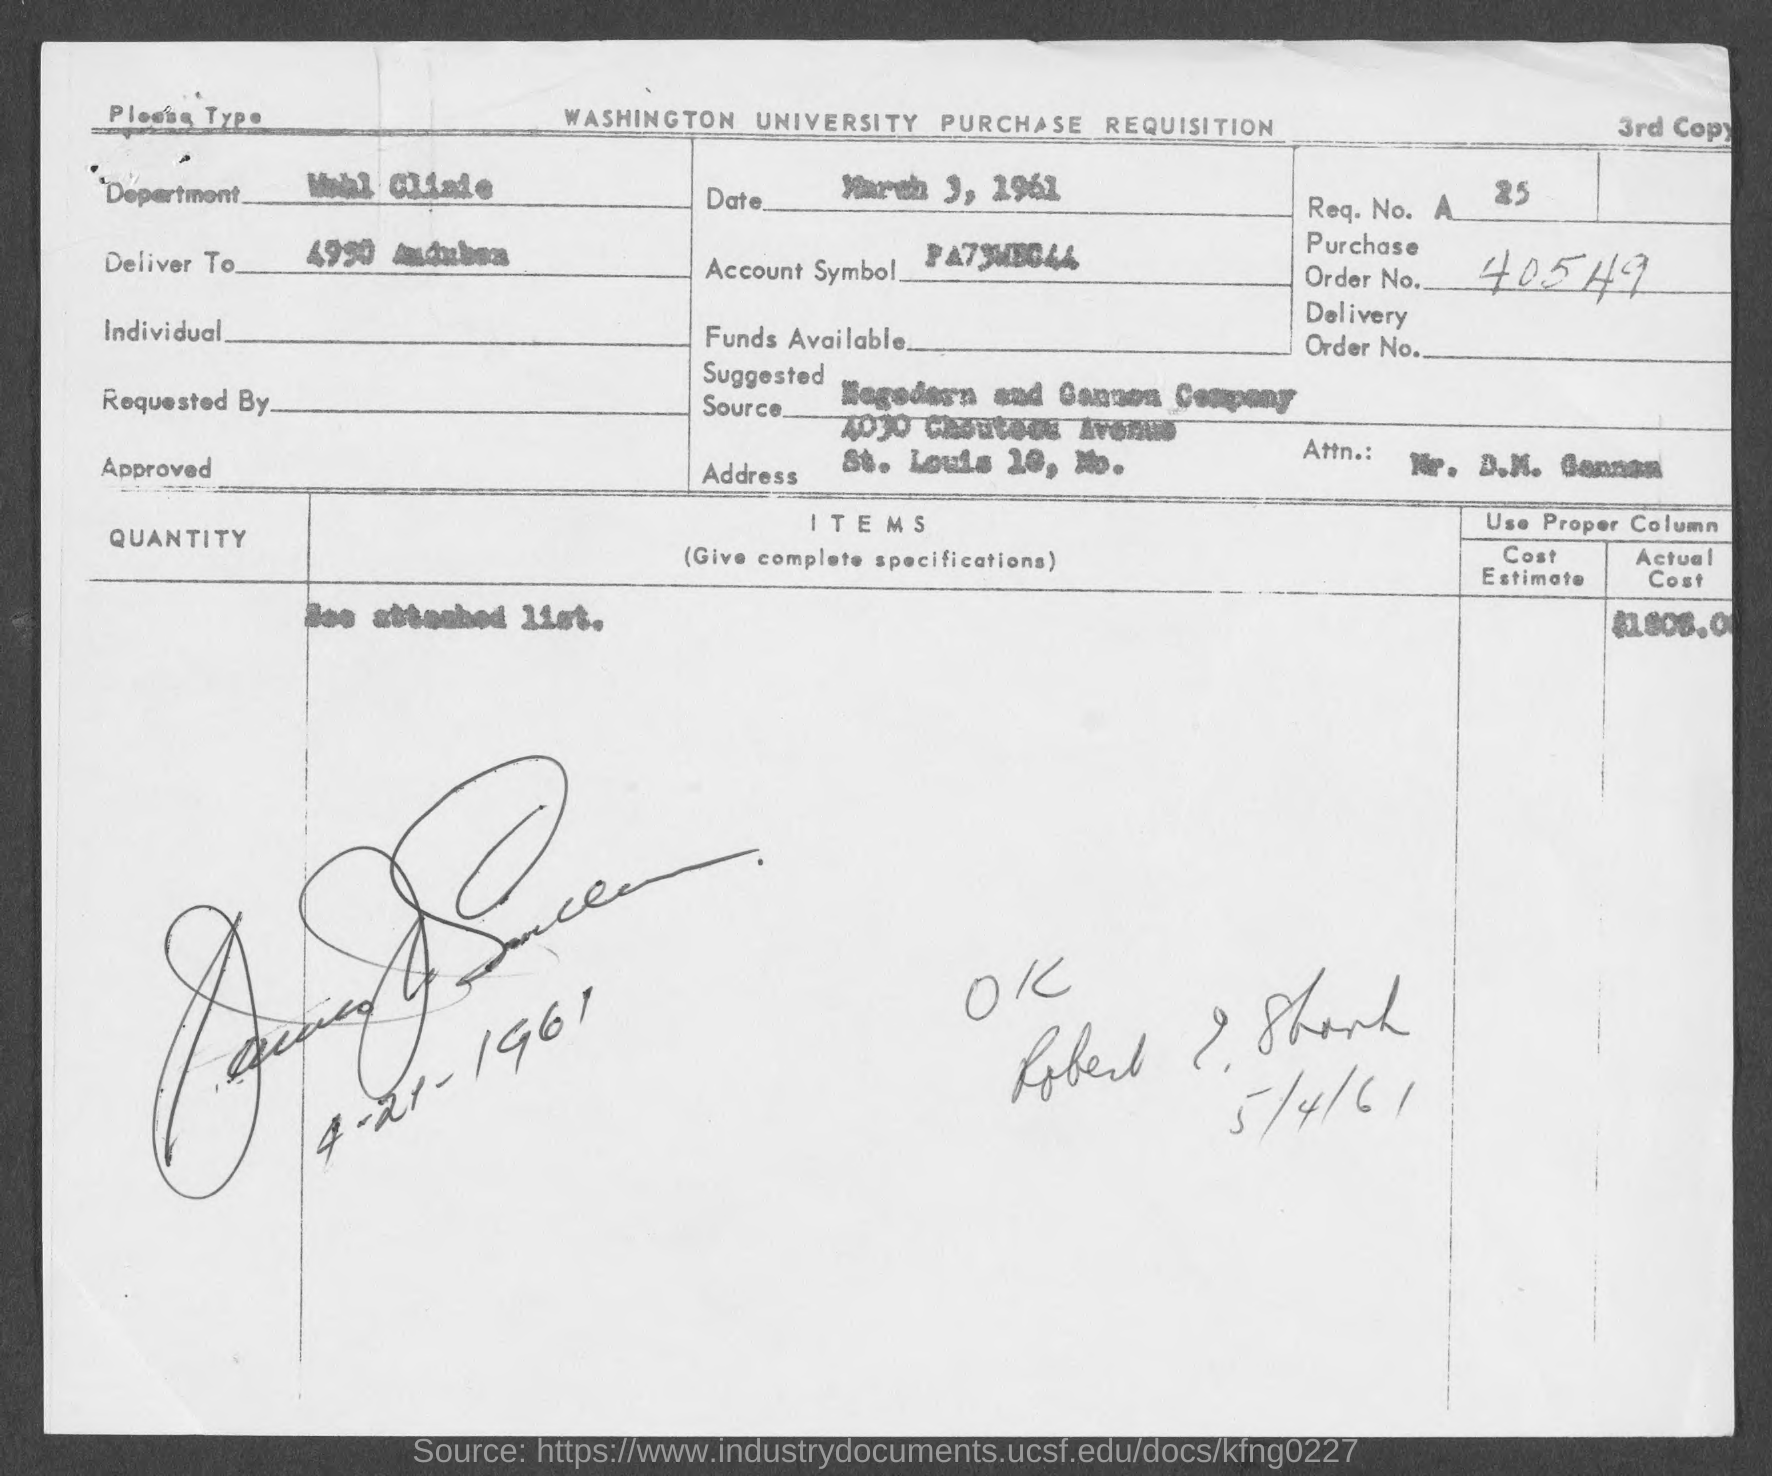Give some essential details in this illustration. The Order Number is 40549... On March 3, 1961, the date is... 